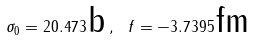<formula> <loc_0><loc_0><loc_500><loc_500>\sigma _ { 0 } = 2 0 . 4 7 3 \, \text {b} \, , \text { } f = - 3 . 7 3 9 5 \, \text {fm}</formula> 